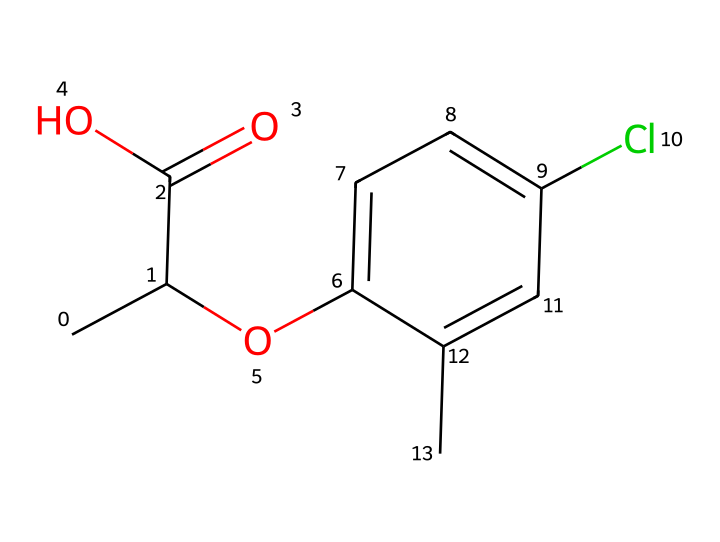How many carbon atoms are present in mecoprop? The SMILES representation shows multiple "C" characters. Counting the unique carbon atoms, there are six in the main chain and the aromatic ring combined.
Answer: six What functional groups are present in mecoprop? Observing the structure, mecoprop has a carboxylic acid (-COOH) and an ether (-O-) functional group due to the arrangement of oxygen and carbon atoms.
Answer: carboxylic acid, ether How many chlorine atoms are in mecoprop? The chemical structure indicates the presence of one "Cl" in the aromatic ring of mecoprop, signifying one chlorine atom.
Answer: one What type of herbicide is mecoprop classified as? Mecoprop is a selective herbicide targeting broadleaf weeds while being less harmful to grass, which is a specific characteristic of certain herbicides.
Answer: selective herbicide What is the role of the carboxylic acid group in mecoprop's activity? The carboxylic acid group contributes to the herbicide's chemical properties, allowing it to interact with plant growth processes, which is crucial for its effectiveness as a herbicide.
Answer: interaction with plant growth processes How does the molecular structure of mecoprop help in controlling broadleaf weeds? The specific arrangement of functional groups in mecoprop is designed to disrupt processes in broadleaf plants while minimizing damage to grassy areas, highlighting its selectivity as a herbicide.
Answer: disrupts processes in broadleaf plants 